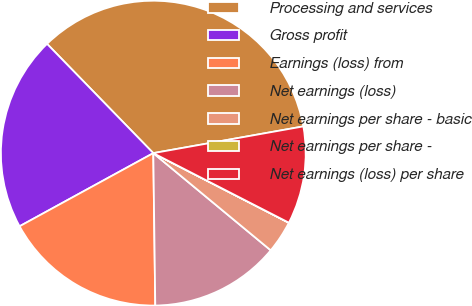Convert chart. <chart><loc_0><loc_0><loc_500><loc_500><pie_chart><fcel>Processing and services<fcel>Gross profit<fcel>Earnings (loss) from<fcel>Net earnings (loss)<fcel>Net earnings per share - basic<fcel>Net earnings per share -<fcel>Net earnings (loss) per share<nl><fcel>34.47%<fcel>20.69%<fcel>17.24%<fcel>13.79%<fcel>3.45%<fcel>0.01%<fcel>10.35%<nl></chart> 